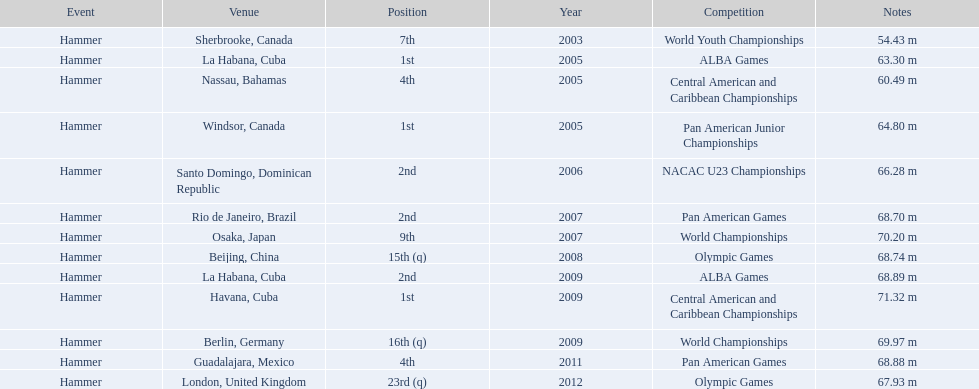Parse the full table. {'header': ['Event', 'Venue', 'Position', 'Year', 'Competition', 'Notes'], 'rows': [['Hammer', 'Sherbrooke, Canada', '7th', '2003', 'World Youth Championships', '54.43 m'], ['Hammer', 'La Habana, Cuba', '1st', '2005', 'ALBA Games', '63.30 m'], ['Hammer', 'Nassau, Bahamas', '4th', '2005', 'Central American and Caribbean Championships', '60.49 m'], ['Hammer', 'Windsor, Canada', '1st', '2005', 'Pan American Junior Championships', '64.80 m'], ['Hammer', 'Santo Domingo, Dominican Republic', '2nd', '2006', 'NACAC U23 Championships', '66.28 m'], ['Hammer', 'Rio de Janeiro, Brazil', '2nd', '2007', 'Pan American Games', '68.70 m'], ['Hammer', 'Osaka, Japan', '9th', '2007', 'World Championships', '70.20 m'], ['Hammer', 'Beijing, China', '15th (q)', '2008', 'Olympic Games', '68.74 m'], ['Hammer', 'La Habana, Cuba', '2nd', '2009', 'ALBA Games', '68.89 m'], ['Hammer', 'Havana, Cuba', '1st', '2009', 'Central American and Caribbean Championships', '71.32 m'], ['Hammer', 'Berlin, Germany', '16th (q)', '2009', 'World Championships', '69.97 m'], ['Hammer', 'Guadalajara, Mexico', '4th', '2011', 'Pan American Games', '68.88 m'], ['Hammer', 'London, United Kingdom', '23rd (q)', '2012', 'Olympic Games', '67.93 m']]} What is the number of competitions held in cuba? 3. 